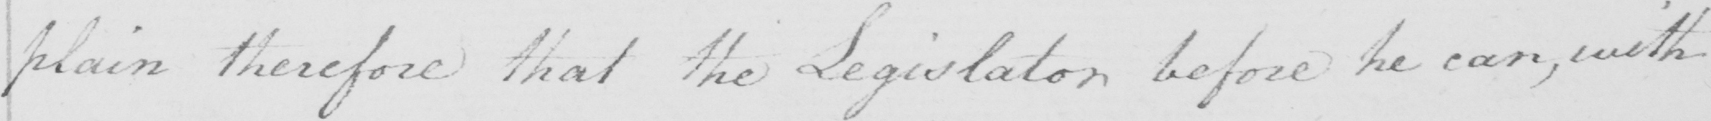What text is written in this handwritten line? plain therefore that the Legislator before he can , with 